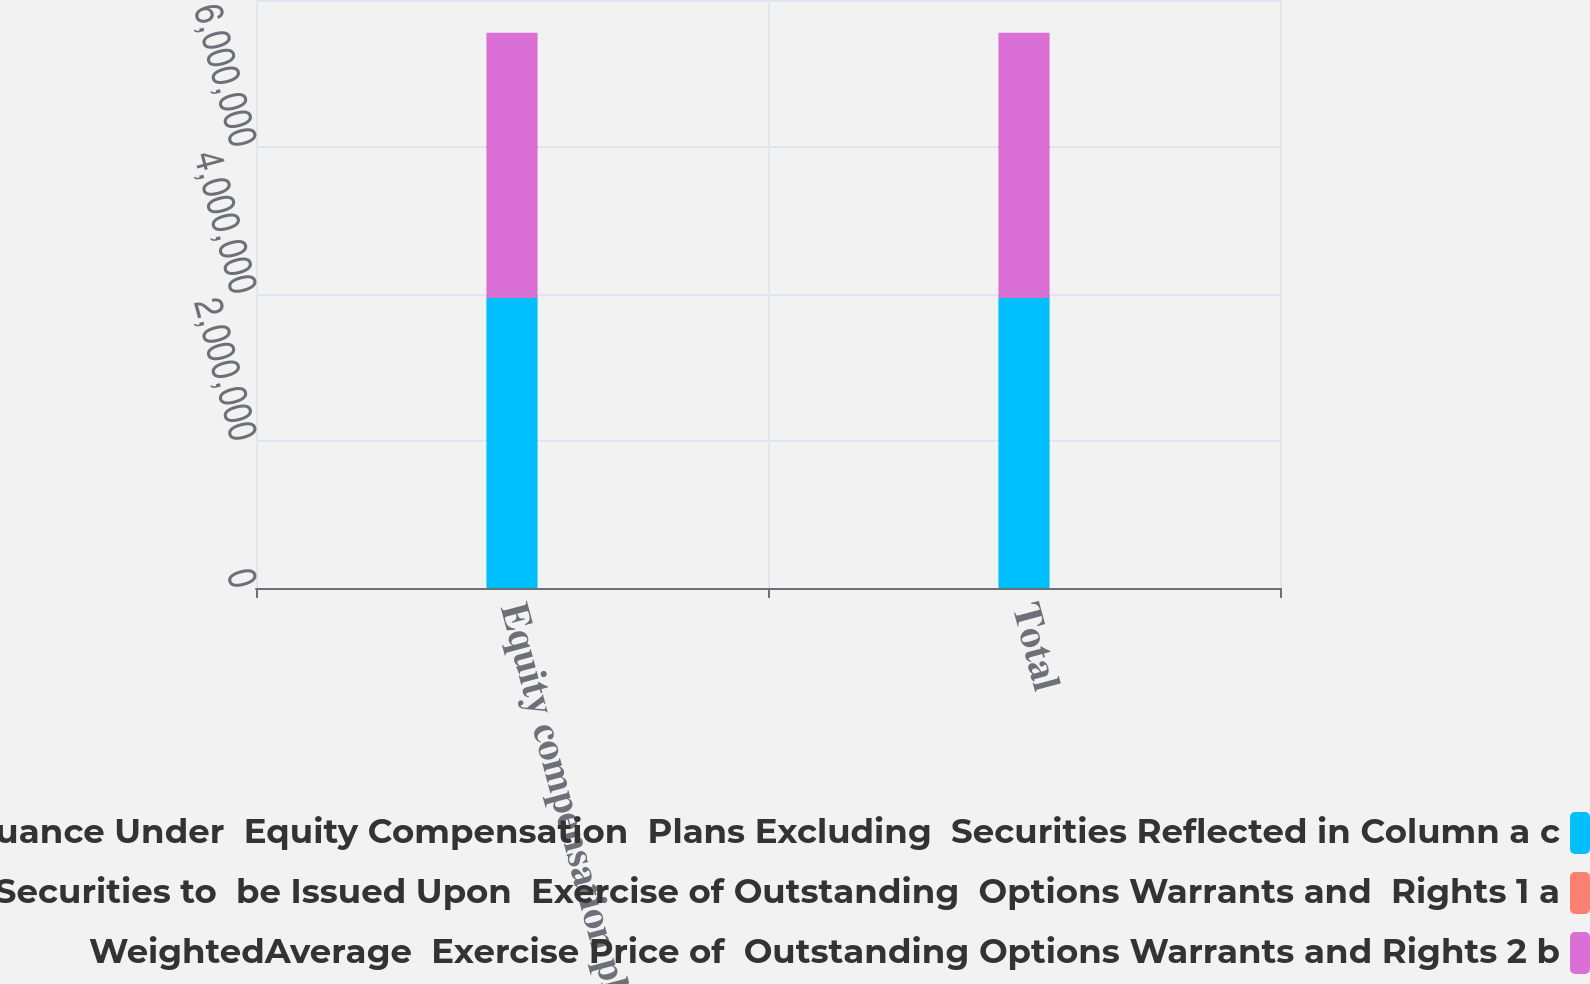Convert chart to OTSL. <chart><loc_0><loc_0><loc_500><loc_500><stacked_bar_chart><ecel><fcel>Equity compensation plans<fcel>Total<nl><fcel>Number of Securities  Remaining Available for  Future Issuance Under  Equity Compensation  Plans Excluding  Securities Reflected in Column a c<fcel>3.94611e+06<fcel>3.94611e+06<nl><fcel>Number of Securities to  be Issued Upon  Exercise of Outstanding  Options Warrants and  Rights 1 a<fcel>34.67<fcel>34.67<nl><fcel>WeightedAverage  Exercise Price of  Outstanding Options Warrants and Rights 2 b<fcel>3.60853e+06<fcel>3.60853e+06<nl></chart> 